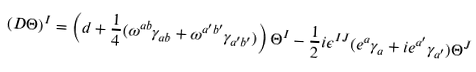<formula> <loc_0><loc_0><loc_500><loc_500>( D \Theta ) ^ { I } = \left ( d + { \frac { 1 } { 4 } } ( \omega ^ { a b } \gamma _ { a b } + \omega ^ { a ^ { \prime } b ^ { \prime } } \gamma _ { a ^ { \prime } b ^ { \prime } } ) \right ) \Theta ^ { I } - { \frac { 1 } { 2 } } i \epsilon ^ { I J } ( e ^ { a } \gamma _ { a } + i e ^ { a ^ { \prime } } \gamma _ { a ^ { \prime } } ) \Theta ^ { J }</formula> 